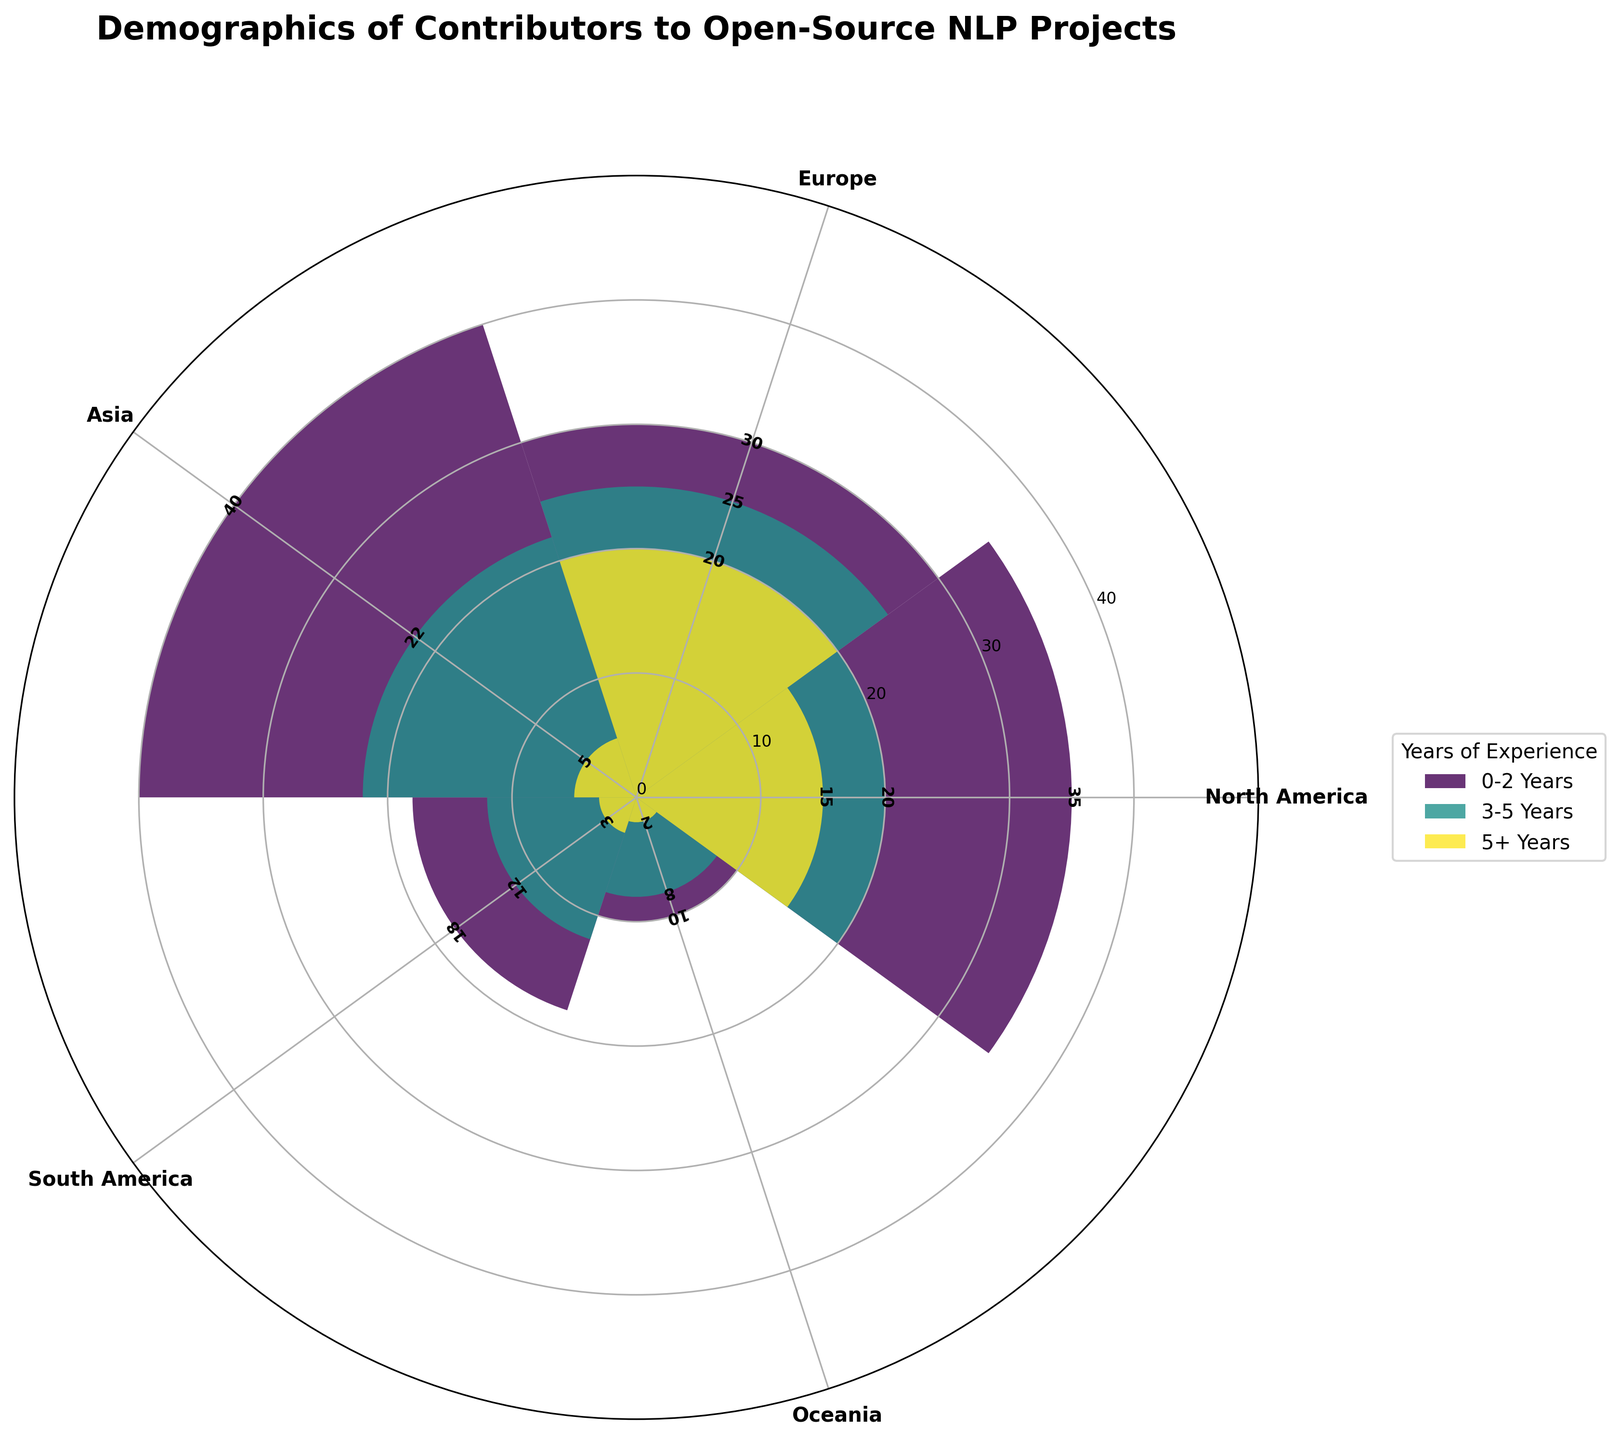What's the title of the figure? The title of the plot is clearly displayed at the top and reads "Demographics of Contributors to Open-Source NLP Projects".
Answer: Demographics of Contributors to Open-Source NLP Projects Which geographical location has the most contributors with 0-2 years of experience? By examining the length of the corresponding bar for each geographical location, Asia has the longest bar for the 0-2 years experience category.
Answer: Asia How many total contributors are there from Europe with master's degrees? Summing up the contributors from Europe with 3-5 years of experience (25).
Answer: 25 Which education level is represented by the least number of contributors in Oceania? By comparing the heights of bars for each education level in Oceania, the PhD category (5+ years) has the shortest bar.
Answer: PhD How do the number of contributors with PhDs compare between North America and Europe? The bars for Contributors with PhDs (5+ years) show North America has 15 and Europe has 20.
Answer: Europe has more Summing the number of contributors with 0-2 years of experience in all locations, what is the total? Adding the numbers for all locations for the 0-2 years category: North America (35) + Europe (30) + Asia (40) + South America (18) + Oceania (10) = 133.
Answer: 133 Which location has the highest number of contributors overall? By summing the heights of all bars (contributors) for each location, Asia has the highest combined total.
Answer: Asia What's the difference between the number of contributors with 3-5 years of experience in Asia and South America? Subtract the number from South America (12) from the one in Asia (22) to get 22 - 12 = 10.
Answer: 10 Among contributors with 0-2 years of experience, how many more contributors are there in North America than in South America? Subtract the number of contributors in South America (18) from the number in North America (35) to get 35 - 18 = 17.
Answer: 17 How does the distribution of contributors with 5+ years of experience compare across different regions? Comparing each bar for 5+ years experience: North America (15), Europe (20), Asia (5), South America (3), Oceania (2) shows Asia, South America, and Oceania have fewer contributors compared to North America and Europe.
Answer: North America and Europe have more 